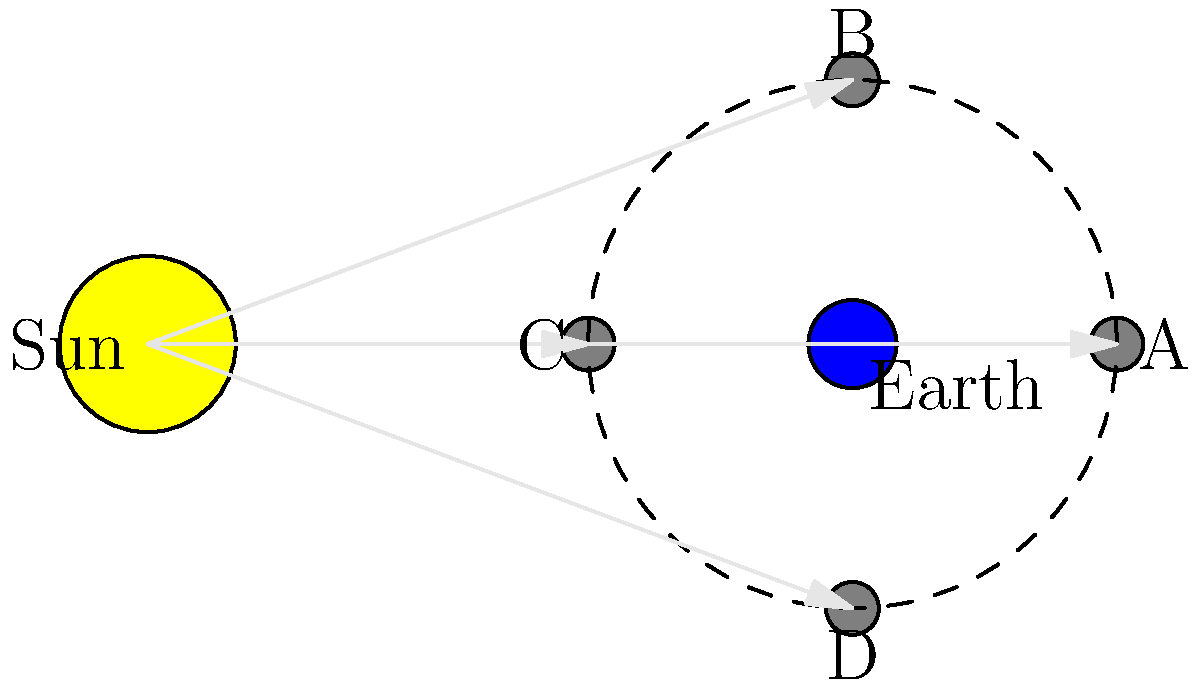Considerando o diagrama que mostra as posições relativas do Sol, Terra e Lua, qual posição da Lua (A, B, C ou D) corresponde à fase de Lua Cheia, e por que esta fase é relevante para o desenvolvimento de aplicativos móveis de astronomia? Para responder a esta pergunta, vamos analisar o diagrama e as fases da Lua passo a passo:

1. A Lua Cheia ocorre quando a face da Lua voltada para a Terra está completamente iluminada pelo Sol.

2. Isso acontece quando a Lua está no lado oposto da Terra em relação ao Sol.

3. Observando o diagrama:
   - Posição A: Lua Nova (não visível da Terra)
   - Posição B: Quarto Crescente
   - Posição C: Lua Cheia
   - Posição D: Quarto Minguante

4. A posição C é a única em que a Lua está diretamente oposta ao Sol, vista da Terra.

5. Relevância para aplicativos móveis de astronomia:
   - A Lua Cheia é facilmente observável e identificável, tornando-a um ponto de referência útil para usuários iniciantes.
   - Pode ser usada para calibrar sensores de luz em dispositivos móveis para observações astronômicas.
   - Algoritmos de IA podem ser treinados para reconhecer fases lunares em imagens capturadas por câmeras de smartphones.
   - Aplicativos podem usar a fase da Lua Cheia para programar lembretes de observação ou fornecer informações sobre fenômenos relacionados (como eclipses lunares).
   - Machine learning pode ser aplicado para prever condições de observação baseadas em padrões históricos durante a Lua Cheia.

Portanto, a posição C representa a Lua Cheia, que é uma fase lunar importante para o desenvolvimento de aplicativos móveis de astronomia devido à sua visibilidade e potencial para várias aplicações de IA e aprendizado de máquina.
Answer: C (Lua Cheia) 